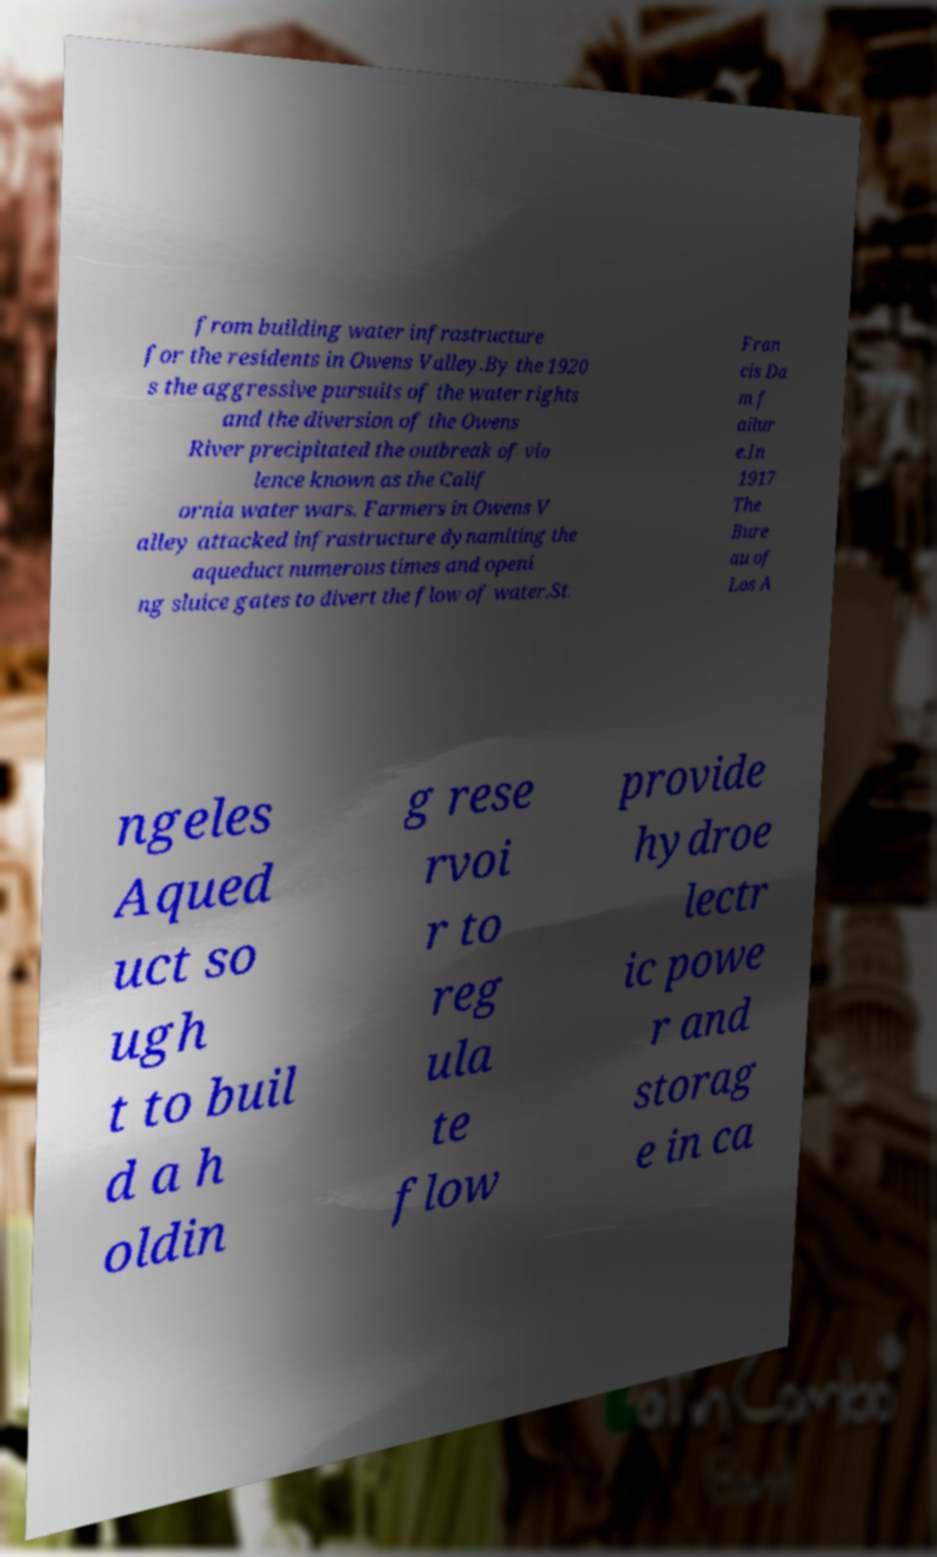Could you extract and type out the text from this image? from building water infrastructure for the residents in Owens Valley.By the 1920 s the aggressive pursuits of the water rights and the diversion of the Owens River precipitated the outbreak of vio lence known as the Calif ornia water wars. Farmers in Owens V alley attacked infrastructure dynamiting the aqueduct numerous times and openi ng sluice gates to divert the flow of water.St. Fran cis Da m f ailur e.In 1917 The Bure au of Los A ngeles Aqued uct so ugh t to buil d a h oldin g rese rvoi r to reg ula te flow provide hydroe lectr ic powe r and storag e in ca 